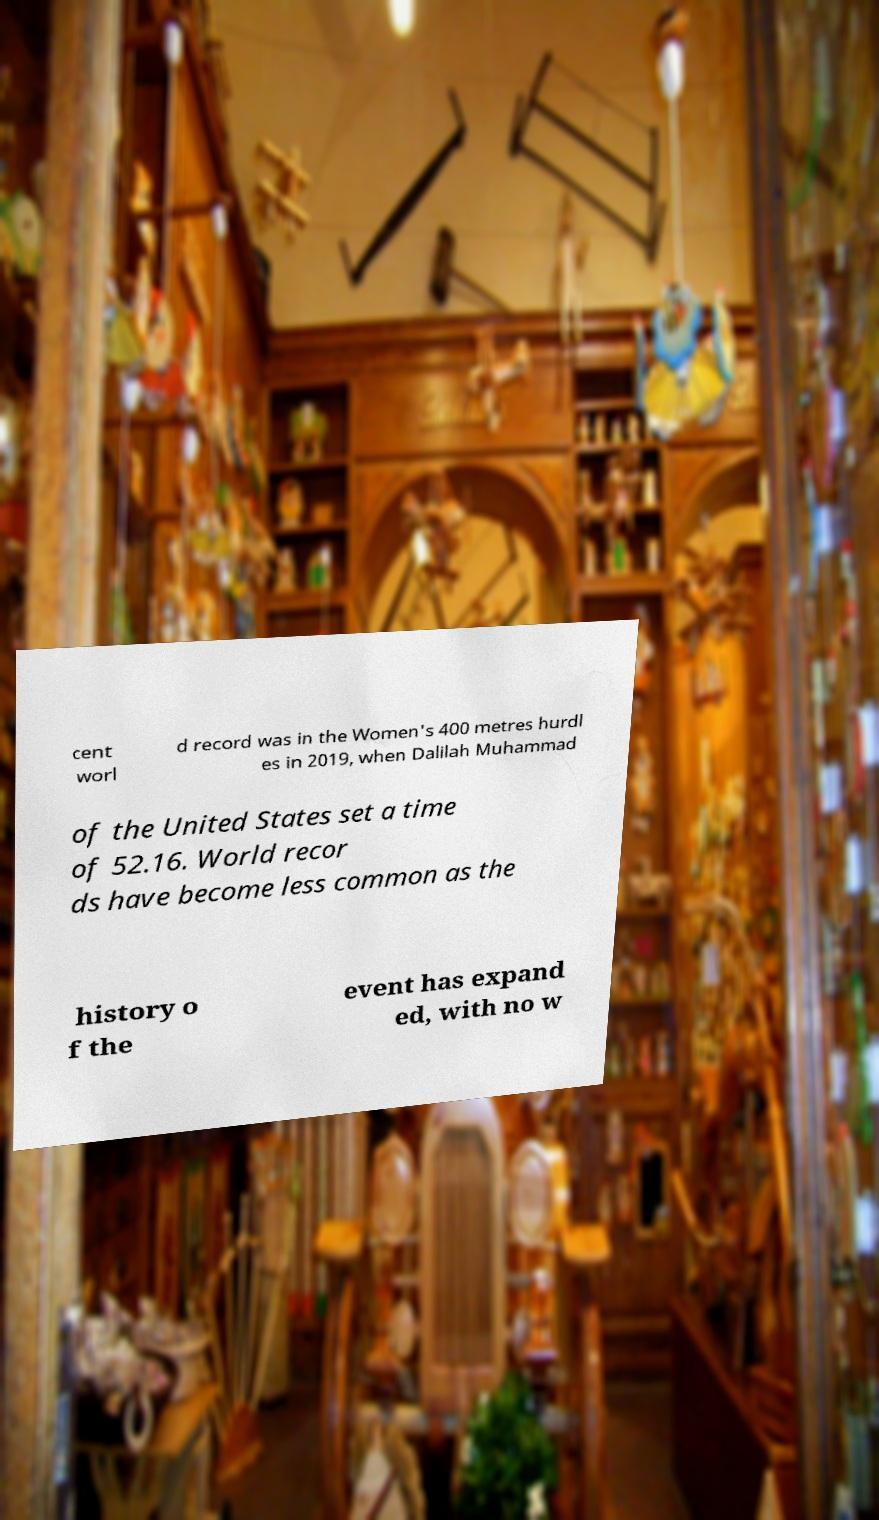What messages or text are displayed in this image? I need them in a readable, typed format. cent worl d record was in the Women's 400 metres hurdl es in 2019, when Dalilah Muhammad of the United States set a time of 52.16. World recor ds have become less common as the history o f the event has expand ed, with no w 